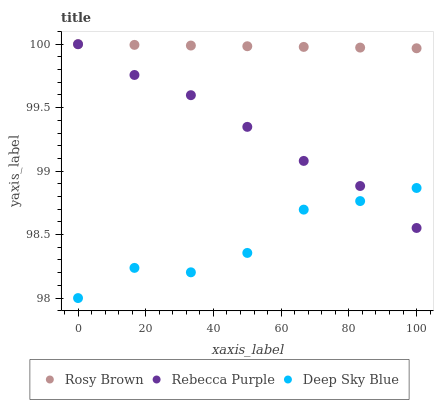Does Deep Sky Blue have the minimum area under the curve?
Answer yes or no. Yes. Does Rosy Brown have the maximum area under the curve?
Answer yes or no. Yes. Does Rebecca Purple have the minimum area under the curve?
Answer yes or no. No. Does Rebecca Purple have the maximum area under the curve?
Answer yes or no. No. Is Rosy Brown the smoothest?
Answer yes or no. Yes. Is Deep Sky Blue the roughest?
Answer yes or no. Yes. Is Rebecca Purple the smoothest?
Answer yes or no. No. Is Rebecca Purple the roughest?
Answer yes or no. No. Does Deep Sky Blue have the lowest value?
Answer yes or no. Yes. Does Rebecca Purple have the lowest value?
Answer yes or no. No. Does Rebecca Purple have the highest value?
Answer yes or no. Yes. Does Deep Sky Blue have the highest value?
Answer yes or no. No. Is Deep Sky Blue less than Rosy Brown?
Answer yes or no. Yes. Is Rosy Brown greater than Deep Sky Blue?
Answer yes or no. Yes. Does Deep Sky Blue intersect Rebecca Purple?
Answer yes or no. Yes. Is Deep Sky Blue less than Rebecca Purple?
Answer yes or no. No. Is Deep Sky Blue greater than Rebecca Purple?
Answer yes or no. No. Does Deep Sky Blue intersect Rosy Brown?
Answer yes or no. No. 